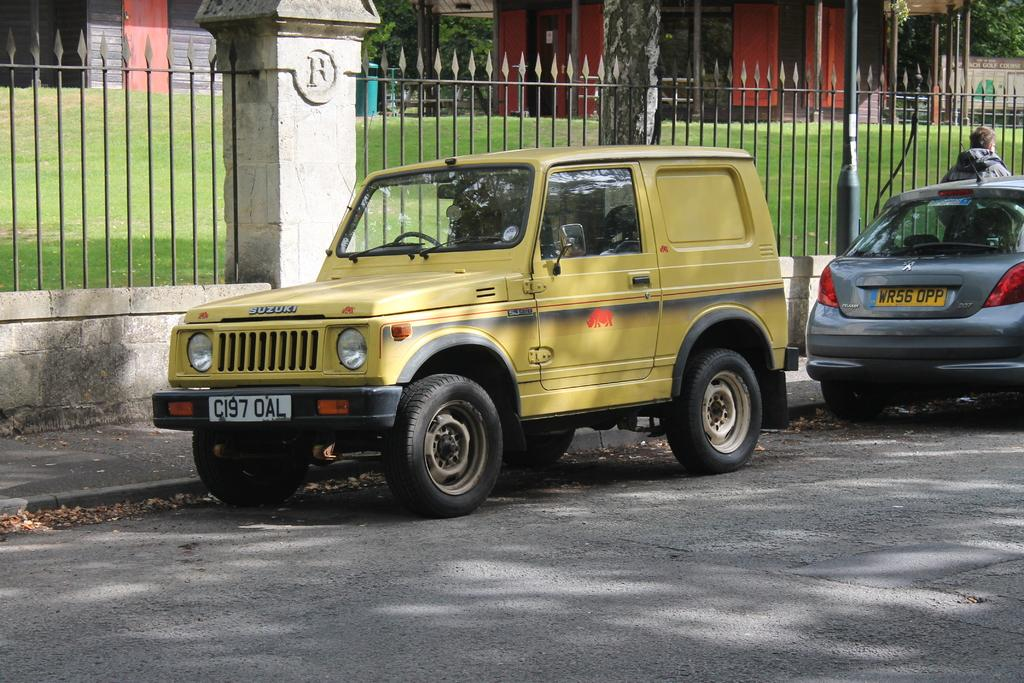What can be seen on the road in the image? There are vehicles on the road in the image. What type of barrier is present in the image? There is a fence in the image. What is covering the ground in the image? The ground is covered with grass. What type of structures are visible in the image? There are buildings in the image. Can you tell me where the beggar is standing in the image? There is no beggar present in the image. What type of quilt is draped over the fence in the image? There is no quilt present in the image. 